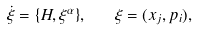<formula> <loc_0><loc_0><loc_500><loc_500>\dot { \xi } = \{ H , \xi ^ { \alpha } \} , \quad \xi = ( x _ { j } , p _ { i } ) ,</formula> 